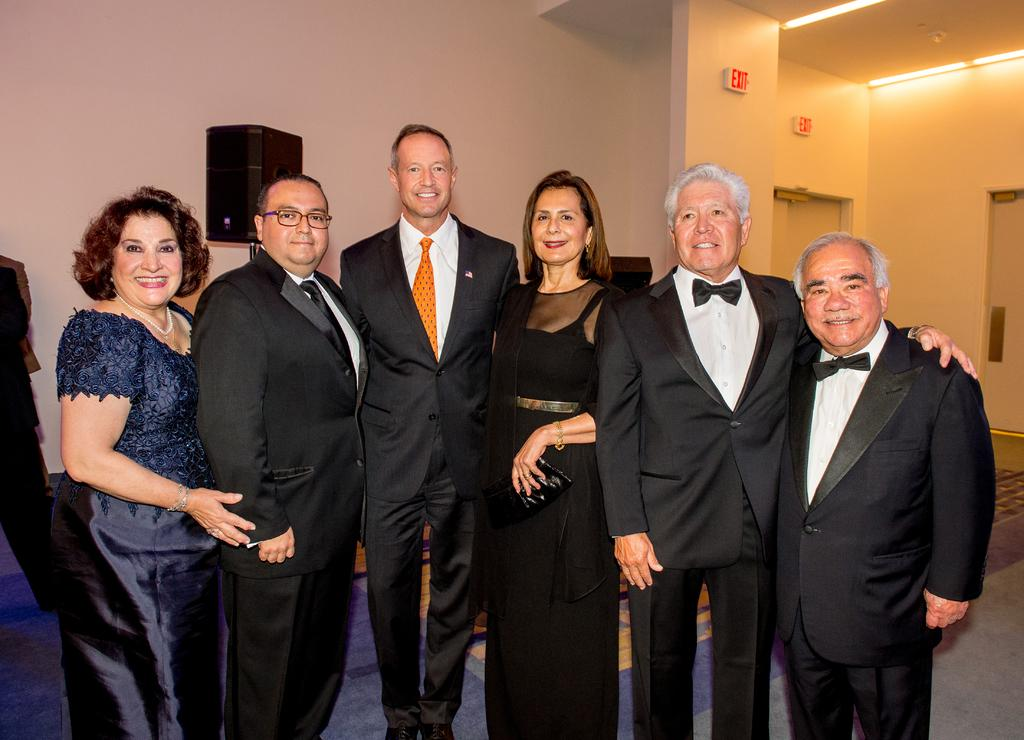What are the people in the image doing? The people in the center of the image are standing and smiling. What can be seen in the background of the image? There is a wall and doors in the background of the image. What object is visible in the image that is used for amplifying sound? There is a speaker visible in the image. What can be seen at the top of the image that provides illumination? There are lights at the top of the image. How many chairs are visible in the image? There are no chairs visible in the image. What type of plane can be seen flying in the background of the image? There is no plane present in the image; it only features people, a wall, doors, a speaker, and lights. 